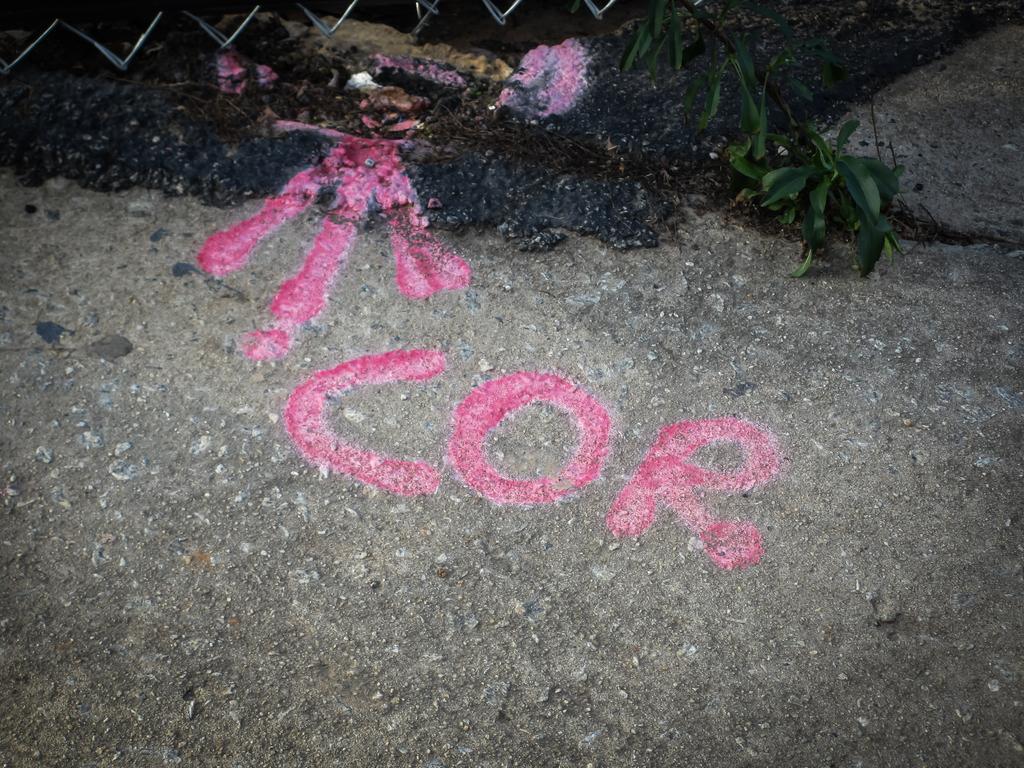Can you describe this image briefly? In the center of the image, we can see a paint on the ground and in the background, we can see a fence and there is a stem of a tree. 